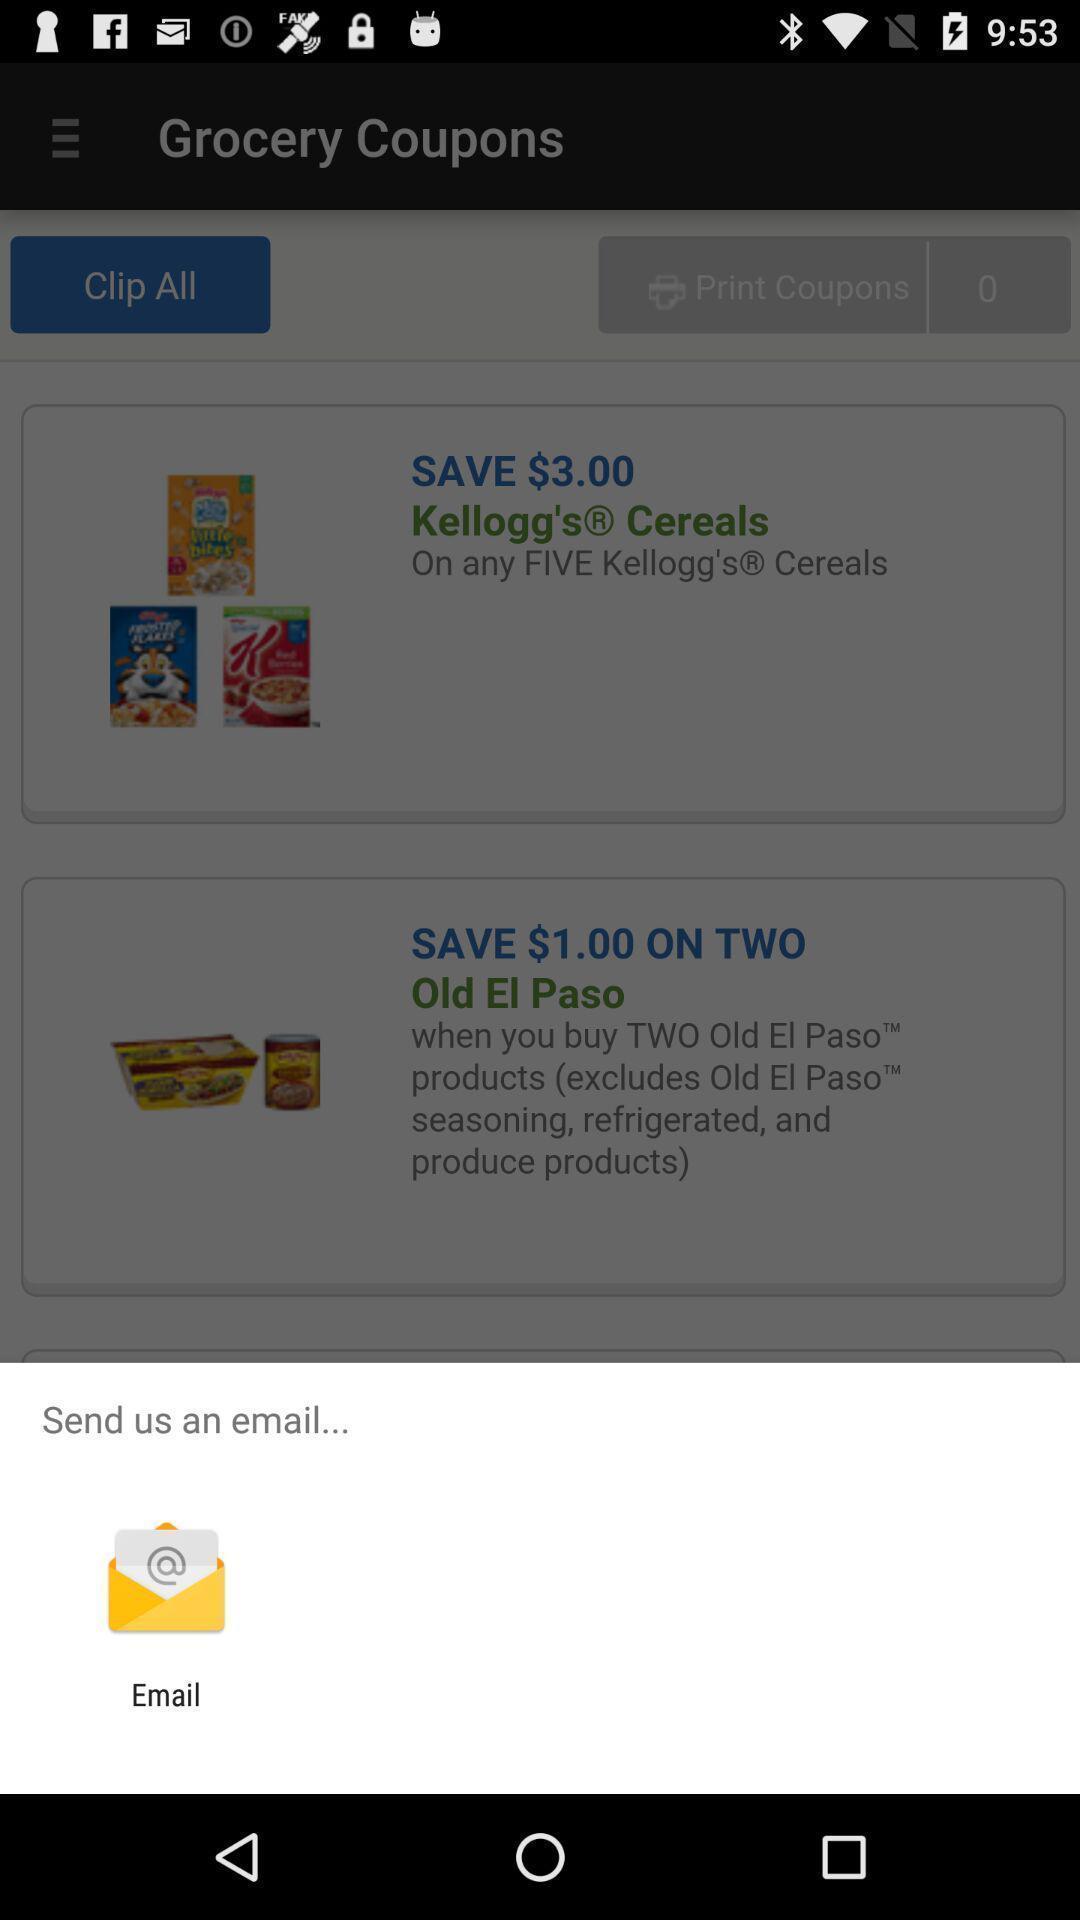Describe the visual elements of this screenshot. Pop-up shows send an email with an app. 